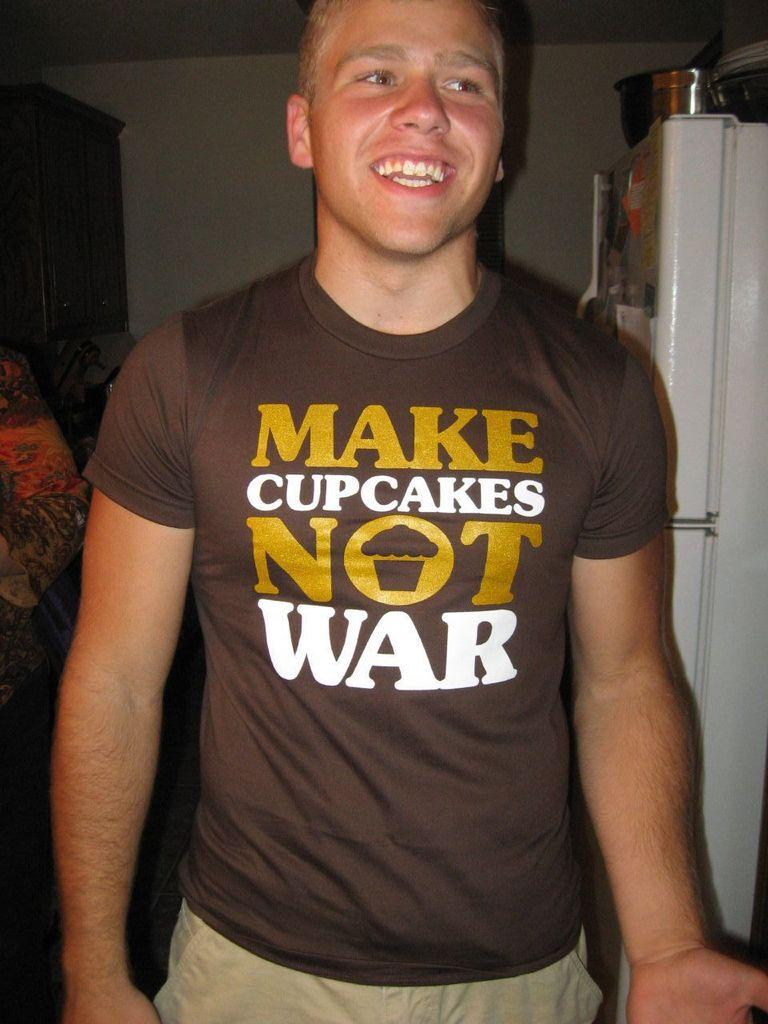<image>
Share a concise interpretation of the image provided. A young man wearing a t shirt that says "make cupcakes not war". 